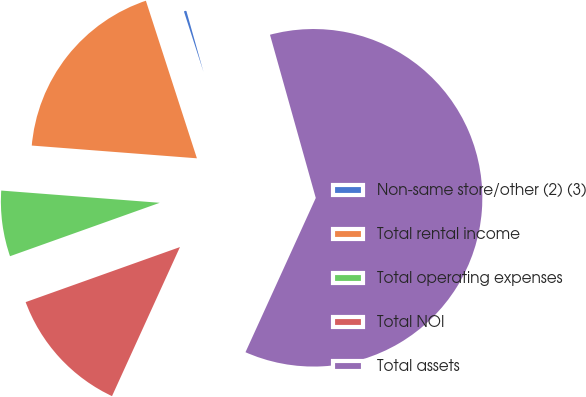<chart> <loc_0><loc_0><loc_500><loc_500><pie_chart><fcel>Non-same store/other (2) (3)<fcel>Total rental income<fcel>Total operating expenses<fcel>Total NOI<fcel>Total assets<nl><fcel>0.63%<fcel>18.79%<fcel>6.68%<fcel>12.74%<fcel>61.16%<nl></chart> 